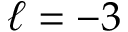Convert formula to latex. <formula><loc_0><loc_0><loc_500><loc_500>\ell = - 3</formula> 